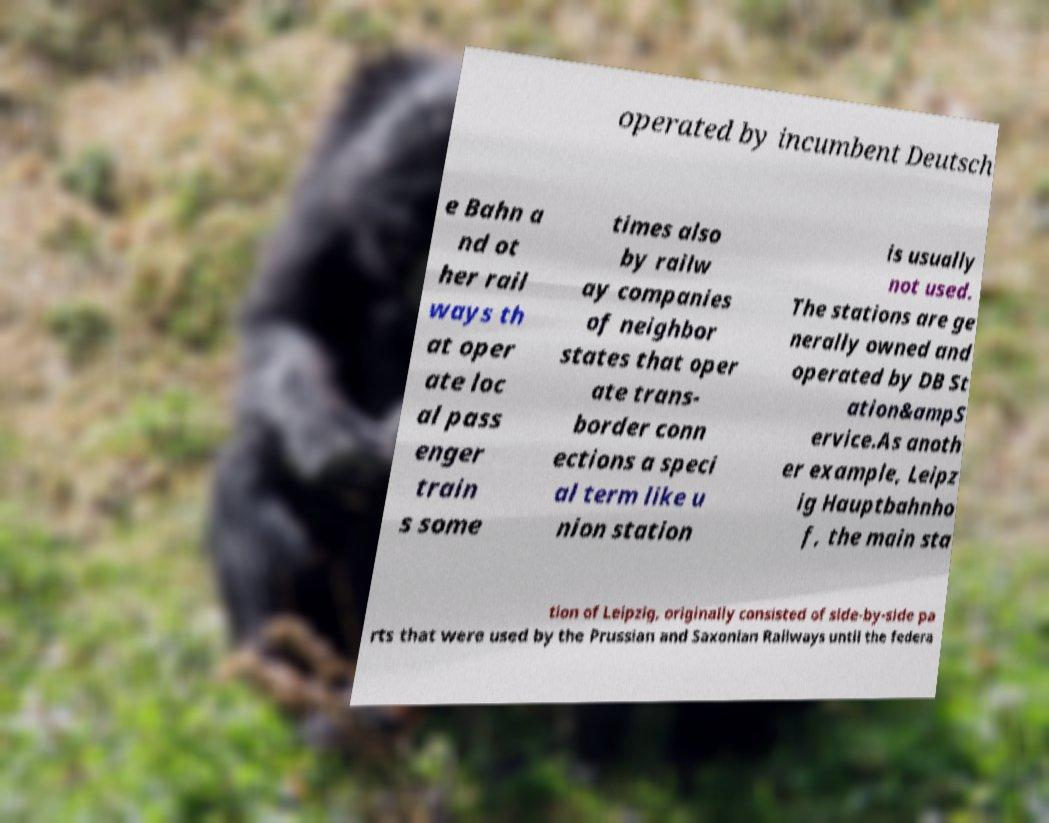Please read and relay the text visible in this image. What does it say? operated by incumbent Deutsch e Bahn a nd ot her rail ways th at oper ate loc al pass enger train s some times also by railw ay companies of neighbor states that oper ate trans- border conn ections a speci al term like u nion station is usually not used. The stations are ge nerally owned and operated by DB St ation&ampS ervice.As anoth er example, Leipz ig Hauptbahnho f, the main sta tion of Leipzig, originally consisted of side-by-side pa rts that were used by the Prussian and Saxonian Railways until the federa 